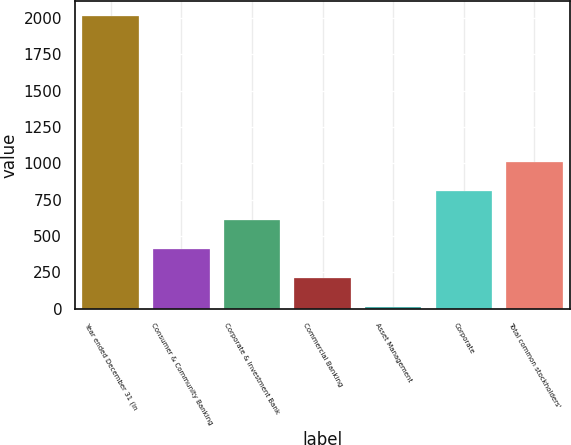Convert chart to OTSL. <chart><loc_0><loc_0><loc_500><loc_500><bar_chart><fcel>Year ended December 31 (in<fcel>Consumer & Community Banking<fcel>Corporate & Investment Bank<fcel>Commercial Banking<fcel>Asset Management<fcel>Corporate<fcel>Total common stockholders'<nl><fcel>2013<fcel>409.8<fcel>610.2<fcel>209.4<fcel>9<fcel>810.6<fcel>1011<nl></chart> 